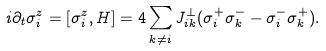<formula> <loc_0><loc_0><loc_500><loc_500>i \partial _ { t } \sigma ^ { z } _ { i } = [ \sigma ^ { z } _ { i } , H ] = 4 \sum _ { k \neq i } J ^ { \perp } _ { i k } ( \sigma ^ { + } _ { i } \sigma ^ { - } _ { k } - \sigma ^ { - } _ { i } \sigma ^ { + } _ { k } ) .</formula> 